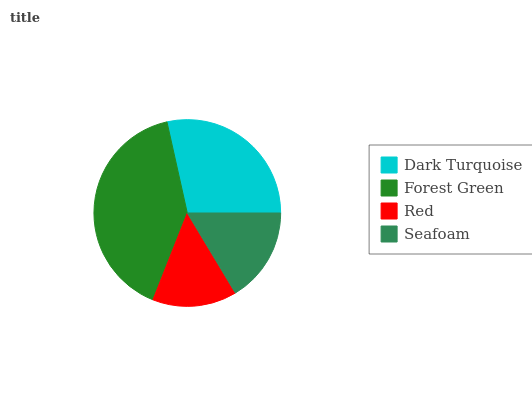Is Red the minimum?
Answer yes or no. Yes. Is Forest Green the maximum?
Answer yes or no. Yes. Is Forest Green the minimum?
Answer yes or no. No. Is Red the maximum?
Answer yes or no. No. Is Forest Green greater than Red?
Answer yes or no. Yes. Is Red less than Forest Green?
Answer yes or no. Yes. Is Red greater than Forest Green?
Answer yes or no. No. Is Forest Green less than Red?
Answer yes or no. No. Is Dark Turquoise the high median?
Answer yes or no. Yes. Is Seafoam the low median?
Answer yes or no. Yes. Is Red the high median?
Answer yes or no. No. Is Red the low median?
Answer yes or no. No. 